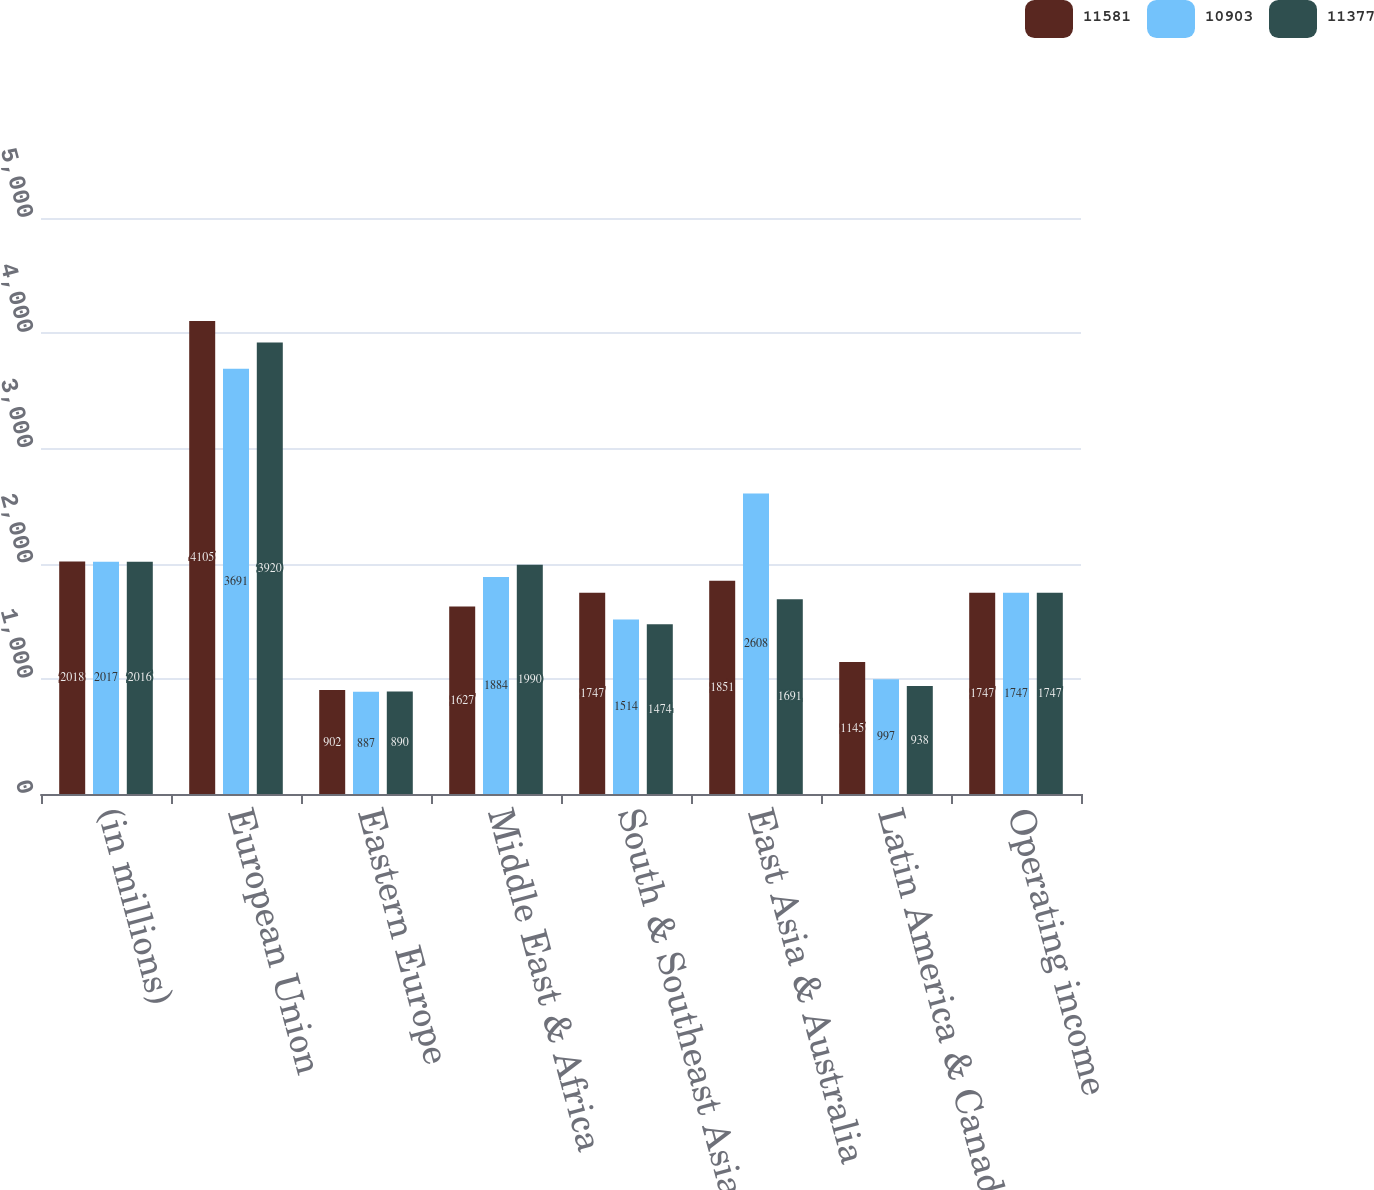<chart> <loc_0><loc_0><loc_500><loc_500><stacked_bar_chart><ecel><fcel>(in millions)<fcel>European Union<fcel>Eastern Europe<fcel>Middle East & Africa<fcel>South & Southeast Asia<fcel>East Asia & Australia<fcel>Latin America & Canada<fcel>Operating income<nl><fcel>11581<fcel>2018<fcel>4105<fcel>902<fcel>1627<fcel>1747<fcel>1851<fcel>1145<fcel>1747<nl><fcel>10903<fcel>2017<fcel>3691<fcel>887<fcel>1884<fcel>1514<fcel>2608<fcel>997<fcel>1747<nl><fcel>11377<fcel>2016<fcel>3920<fcel>890<fcel>1990<fcel>1474<fcel>1691<fcel>938<fcel>1747<nl></chart> 